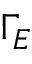Convert formula to latex. <formula><loc_0><loc_0><loc_500><loc_500>\Gamma _ { E }</formula> 